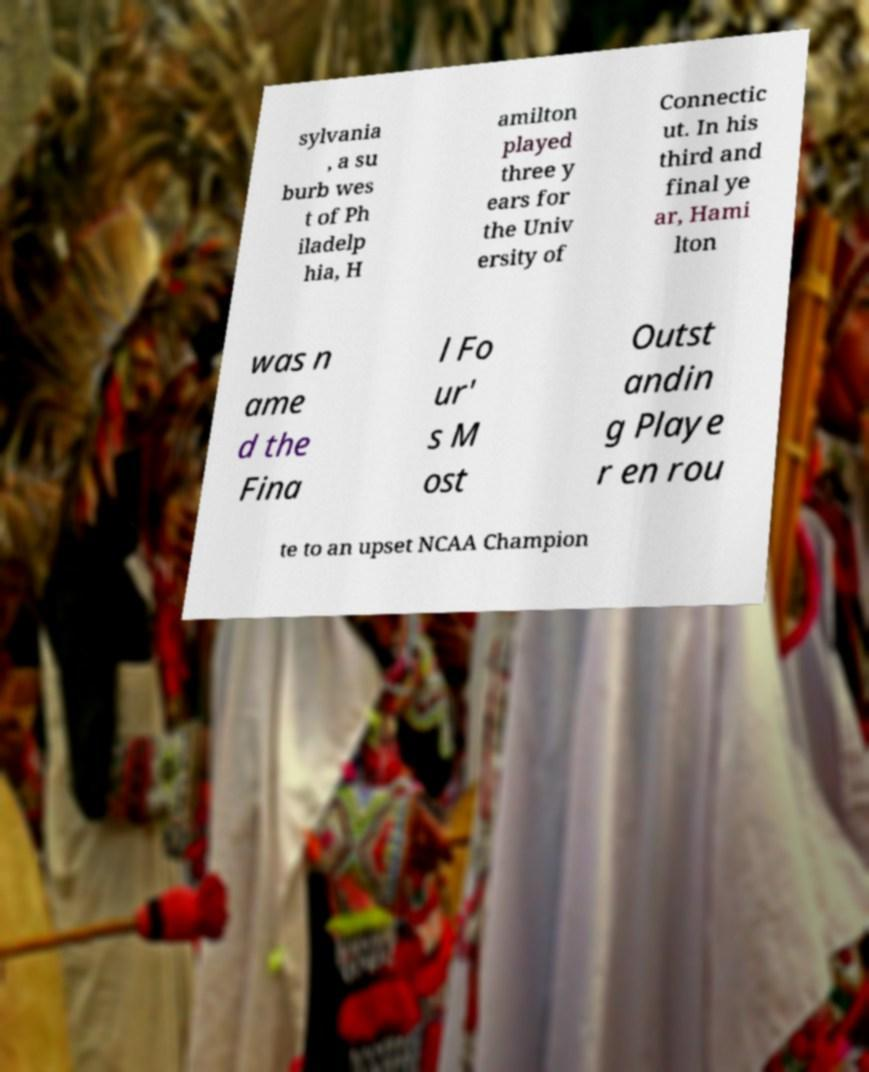Could you extract and type out the text from this image? sylvania , a su burb wes t of Ph iladelp hia, H amilton played three y ears for the Univ ersity of Connectic ut. In his third and final ye ar, Hami lton was n ame d the Fina l Fo ur' s M ost Outst andin g Playe r en rou te to an upset NCAA Champion 